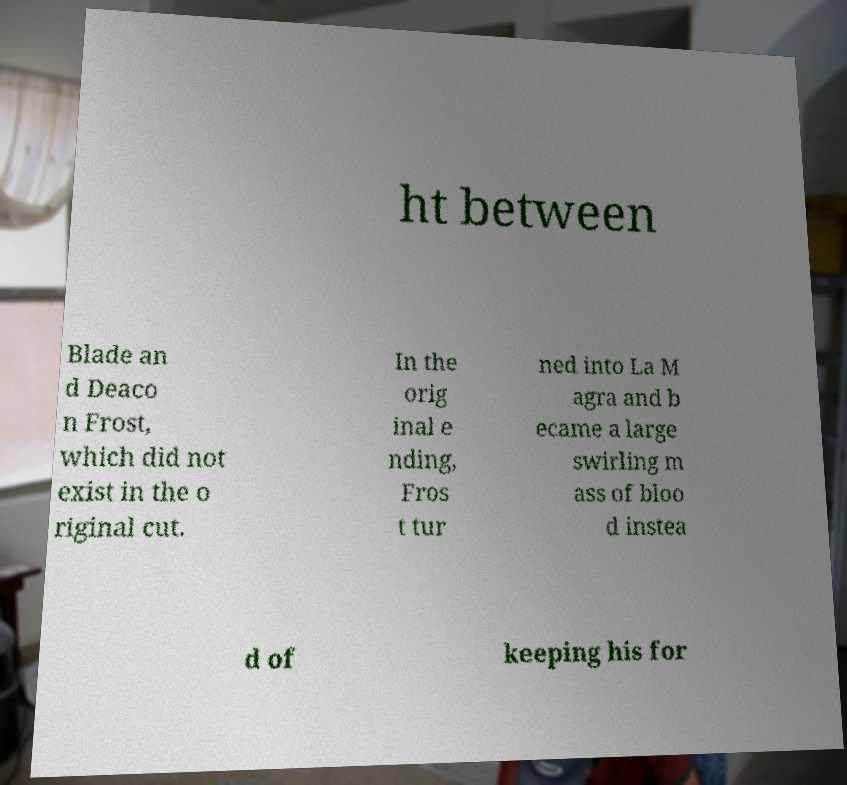Please read and relay the text visible in this image. What does it say? ht between Blade an d Deaco n Frost, which did not exist in the o riginal cut. In the orig inal e nding, Fros t tur ned into La M agra and b ecame a large swirling m ass of bloo d instea d of keeping his for 